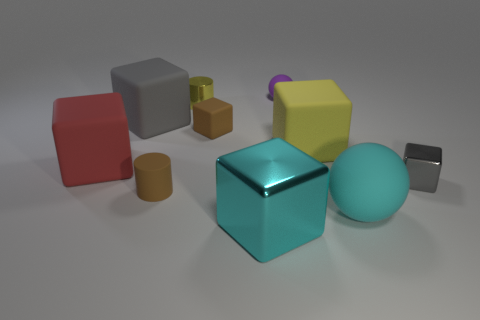Is the red matte thing the same shape as the yellow metal thing?
Ensure brevity in your answer.  No. There is a red object that is the same shape as the yellow rubber object; what material is it?
Offer a terse response. Rubber. What is the color of the matte thing that is in front of the red matte object and to the right of the small yellow object?
Ensure brevity in your answer.  Cyan. The small ball has what color?
Give a very brief answer. Purple. There is a large block that is the same color as the big ball; what is its material?
Offer a terse response. Metal. Are there any other things of the same shape as the tiny yellow metal thing?
Provide a short and direct response. Yes. What is the size of the cyan shiny thing that is on the right side of the yellow metallic object?
Make the answer very short. Large. There is a cyan object that is the same size as the cyan sphere; what is it made of?
Your answer should be very brief. Metal. Is the number of red rubber blocks greater than the number of small brown things?
Give a very brief answer. No. There is a brown rubber thing that is behind the brown object that is in front of the small brown cube; what size is it?
Make the answer very short. Small. 